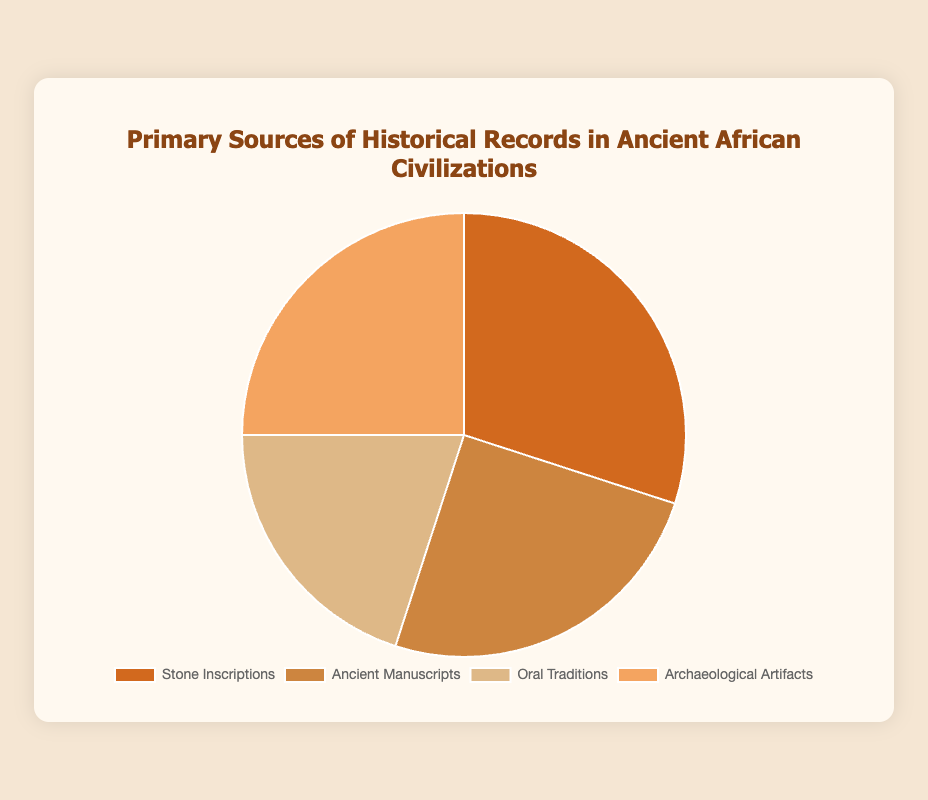What are the two sources with the highest percentage of historical records? Identify the two sources with the highest values in the figure. Stone Inscriptions and Ancient Manuscripts both have 30% and 25% respectively, making them the highest.
Answer: Stone Inscriptions and Ancient Manuscripts Which source has the smallest percentage, and what is that percentage? Look at the smallest value in the figure. Oral Traditions has the smallest percentage at 20%.
Answer: Oral Traditions, 20% Are there any sources that have the same percentage of historical records? If so, which ones? Compare the different values in the figure to identify any ties. Ancient Manuscripts and Archaeological Artifacts both have 25%.
Answer: Ancient Manuscripts and Archaeological Artifacts What is the total percentage accounted for by Oral Traditions and Stone Inscriptions? Sum the percentages for Oral Traditions (20%) and Stone Inscriptions (30%). 20 + 30 equals 50%.
Answer: 50% How much greater is the percentage of Stone Inscriptions compared to Oral Traditions? Subtract the percentage of Oral Traditions (20%) from the percentage of Stone Inscriptions (30%). 30 - 20 equals 10%.
Answer: 10% If you combine the percentages of Ancient Manuscripts and Oral Traditions, what percentage do you get? Add 25% (Ancient Manuscripts) + 20% (Oral Traditions), which results in 45%.
Answer: 45% Which source is represented by the lightest color on the pie chart? Identify the source that is associated with the lightest shade. Typically, visually lighter shades are identified using visual contrast; here, the lightest shade corresponds to Oral Traditions.
Answer: Oral Traditions Of the four sources mentioned, which one has a nearly equal distribution with another source and what are the respective sources? Identify any near-equal percentage values in the figure. Ancient Manuscripts (25%) and Archaeological Artifacts (25%) are nearly equal in distribution.
Answer: Ancient Manuscripts and Archaeological Artifacts What percentage of historical records come from sources other than Stone Inscriptions? Sum the percentages of other sources: 25% (Ancient Manuscripts) + 20% (Oral Traditions) + 25% (Archaeological Artifacts); 25 + 20 + 25 equals 70%.
Answer: 70% If Archaeological Artifacts and Stone Inscriptions were combined, what fraction of the total would they represent? Sum the percentages of Archaeological Artifacts (25%) and Stone Inscriptions (30%): 25 + 30 equals 55%. This can also be expressed as a fraction. 55% out of 100% is 55/100.
Answer: 55/100 